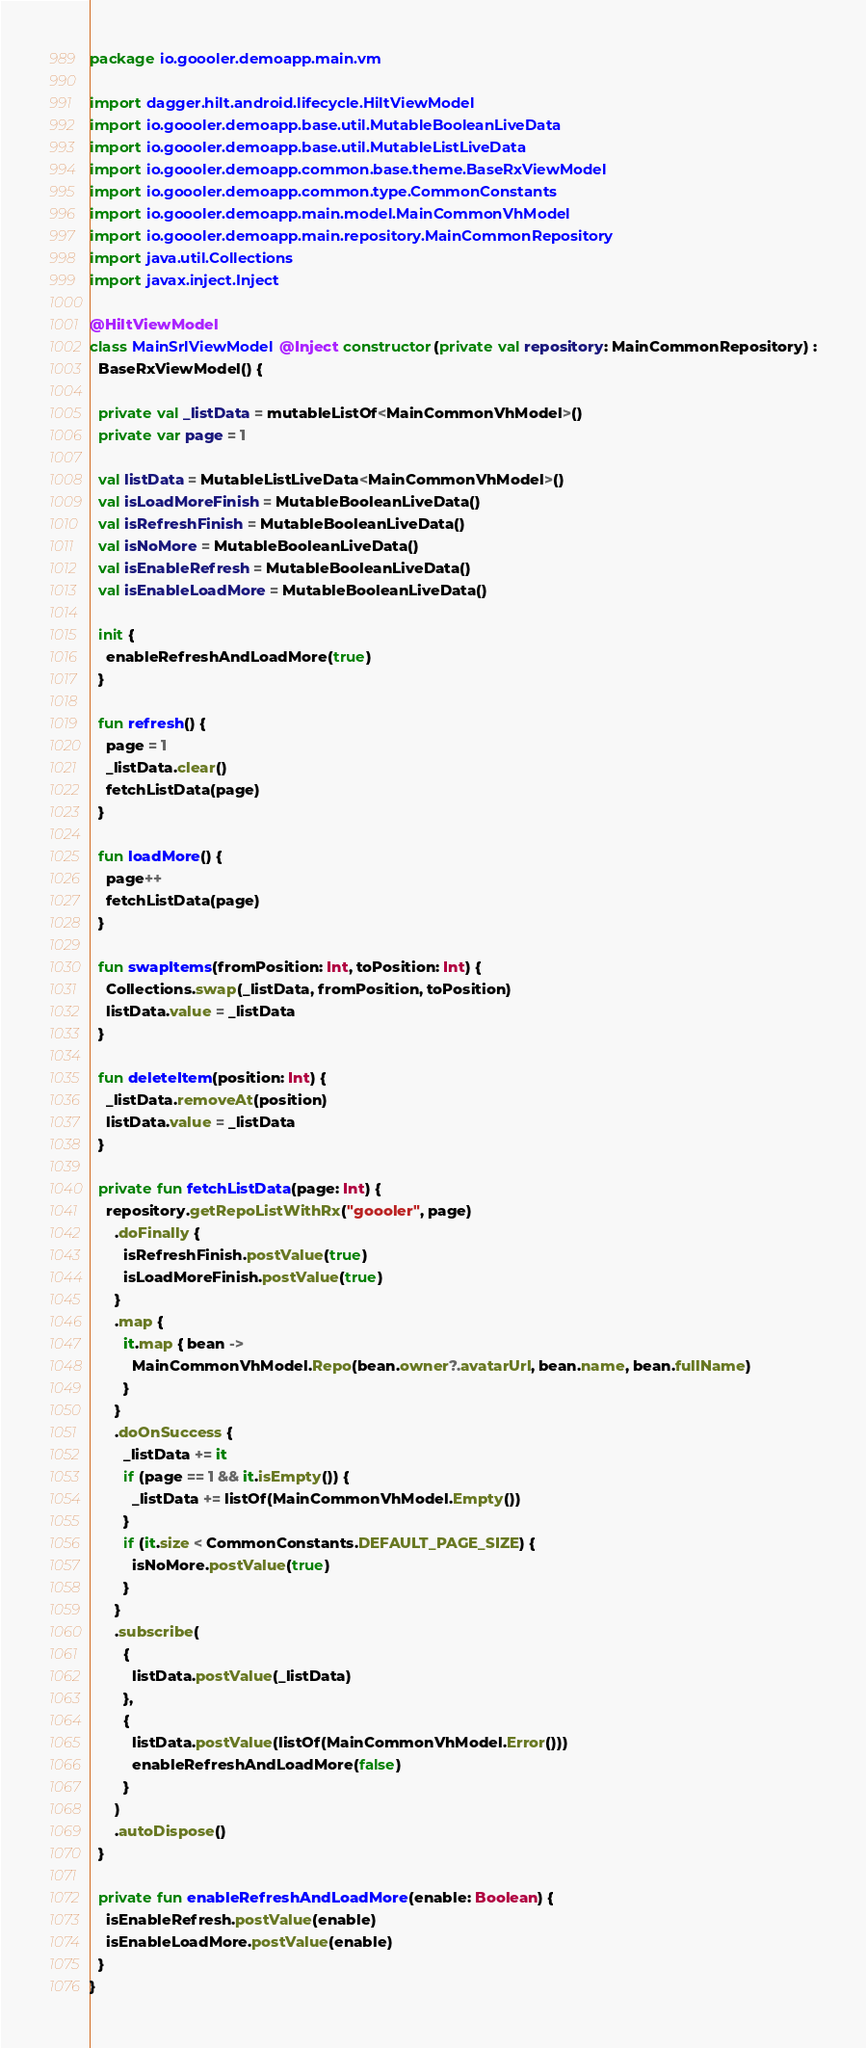<code> <loc_0><loc_0><loc_500><loc_500><_Kotlin_>package io.goooler.demoapp.main.vm

import dagger.hilt.android.lifecycle.HiltViewModel
import io.goooler.demoapp.base.util.MutableBooleanLiveData
import io.goooler.demoapp.base.util.MutableListLiveData
import io.goooler.demoapp.common.base.theme.BaseRxViewModel
import io.goooler.demoapp.common.type.CommonConstants
import io.goooler.demoapp.main.model.MainCommonVhModel
import io.goooler.demoapp.main.repository.MainCommonRepository
import java.util.Collections
import javax.inject.Inject

@HiltViewModel
class MainSrlViewModel @Inject constructor(private val repository: MainCommonRepository) :
  BaseRxViewModel() {

  private val _listData = mutableListOf<MainCommonVhModel>()
  private var page = 1

  val listData = MutableListLiveData<MainCommonVhModel>()
  val isLoadMoreFinish = MutableBooleanLiveData()
  val isRefreshFinish = MutableBooleanLiveData()
  val isNoMore = MutableBooleanLiveData()
  val isEnableRefresh = MutableBooleanLiveData()
  val isEnableLoadMore = MutableBooleanLiveData()

  init {
    enableRefreshAndLoadMore(true)
  }

  fun refresh() {
    page = 1
    _listData.clear()
    fetchListData(page)
  }

  fun loadMore() {
    page++
    fetchListData(page)
  }

  fun swapItems(fromPosition: Int, toPosition: Int) {
    Collections.swap(_listData, fromPosition, toPosition)
    listData.value = _listData
  }

  fun deleteItem(position: Int) {
    _listData.removeAt(position)
    listData.value = _listData
  }

  private fun fetchListData(page: Int) {
    repository.getRepoListWithRx("goooler", page)
      .doFinally {
        isRefreshFinish.postValue(true)
        isLoadMoreFinish.postValue(true)
      }
      .map {
        it.map { bean ->
          MainCommonVhModel.Repo(bean.owner?.avatarUrl, bean.name, bean.fullName)
        }
      }
      .doOnSuccess {
        _listData += it
        if (page == 1 && it.isEmpty()) {
          _listData += listOf(MainCommonVhModel.Empty())
        }
        if (it.size < CommonConstants.DEFAULT_PAGE_SIZE) {
          isNoMore.postValue(true)
        }
      }
      .subscribe(
        {
          listData.postValue(_listData)
        },
        {
          listData.postValue(listOf(MainCommonVhModel.Error()))
          enableRefreshAndLoadMore(false)
        }
      )
      .autoDispose()
  }

  private fun enableRefreshAndLoadMore(enable: Boolean) {
    isEnableRefresh.postValue(enable)
    isEnableLoadMore.postValue(enable)
  }
}
</code> 